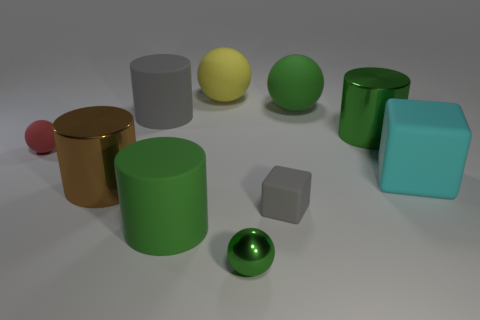Is there another rubber object that has the same size as the cyan thing?
Your answer should be compact. Yes. What is the material of the gray object that is the same size as the cyan object?
Keep it short and to the point. Rubber. There is a cyan block; is it the same size as the gray block on the right side of the big green matte cylinder?
Your answer should be compact. No. What number of matte objects are big purple cylinders or small things?
Provide a short and direct response. 2. What number of other rubber objects are the same shape as the cyan rubber thing?
Offer a very short reply. 1. There is a cylinder that is the same color as the small matte block; what is it made of?
Your answer should be very brief. Rubber. There is a cylinder that is on the left side of the big gray thing; is it the same size as the green shiny thing to the left of the gray rubber cube?
Your answer should be very brief. No. The green object on the left side of the big yellow matte object has what shape?
Provide a short and direct response. Cylinder. There is a large gray object that is the same shape as the brown object; what is its material?
Keep it short and to the point. Rubber. There is a matte cylinder behind the gray rubber cube; is it the same size as the tiny gray cube?
Keep it short and to the point. No. 